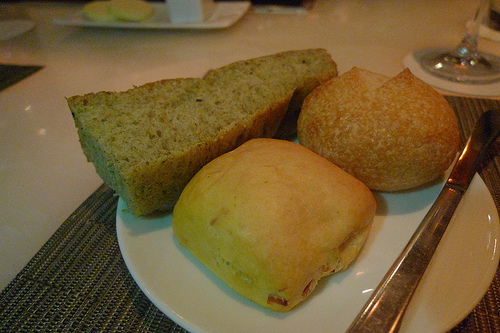<image>
Is the bun under the bread? No. The bun is not positioned under the bread. The vertical relationship between these objects is different. Is the bread on the table? No. The bread is not positioned on the table. They may be near each other, but the bread is not supported by or resting on top of the table. 